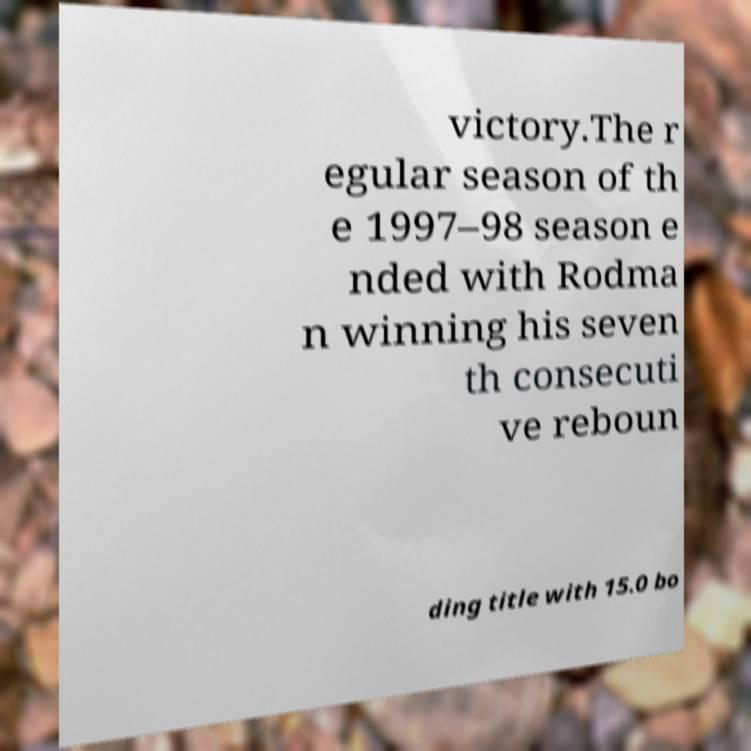Can you accurately transcribe the text from the provided image for me? victory.The r egular season of th e 1997–98 season e nded with Rodma n winning his seven th consecuti ve reboun ding title with 15.0 bo 